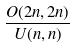<formula> <loc_0><loc_0><loc_500><loc_500>\frac { O ( 2 n , 2 n ) } { U ( n , n ) }</formula> 